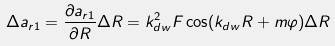Convert formula to latex. <formula><loc_0><loc_0><loc_500><loc_500>\Delta a _ { r 1 } = \frac { \partial a _ { r 1 } } { \partial R } \Delta R = k _ { d w } ^ { 2 } F \cos ( k _ { d w } R + m \varphi ) \Delta R</formula> 